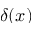Convert formula to latex. <formula><loc_0><loc_0><loc_500><loc_500>\delta ( x )</formula> 